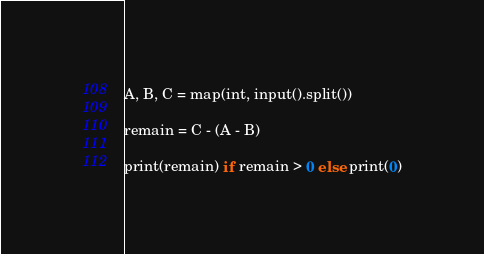Convert code to text. <code><loc_0><loc_0><loc_500><loc_500><_Python_>A, B, C = map(int, input().split())

remain = C - (A - B)

print(remain) if remain > 0 else print(0)
</code> 